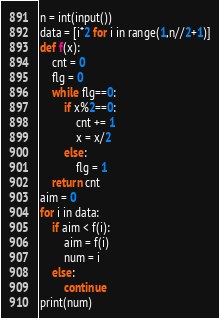Convert code to text. <code><loc_0><loc_0><loc_500><loc_500><_Python_>n = int(input())
data = [i*2 for i in range(1,n//2+1)]
def f(x):
    cnt = 0
    flg = 0
    while flg==0:
        if x%2==0:
            cnt += 1
            x = x/2
        else:
            flg = 1
    return cnt 
aim = 0
for i in data:
    if aim < f(i):
        aim = f(i)
        num = i
    else:
        continue
print(num)    </code> 